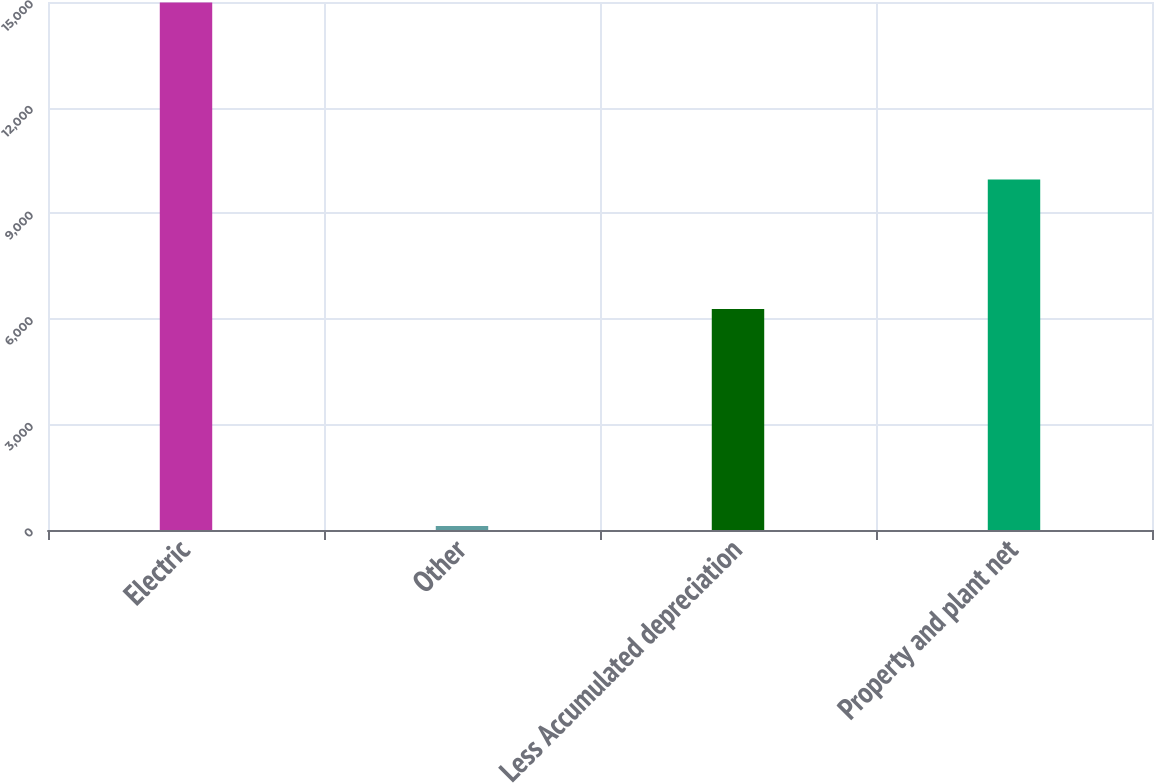Convert chart. <chart><loc_0><loc_0><loc_500><loc_500><bar_chart><fcel>Electric<fcel>Other<fcel>Less Accumulated depreciation<fcel>Property and plant net<nl><fcel>14986<fcel>113<fcel>6276<fcel>9958<nl></chart> 